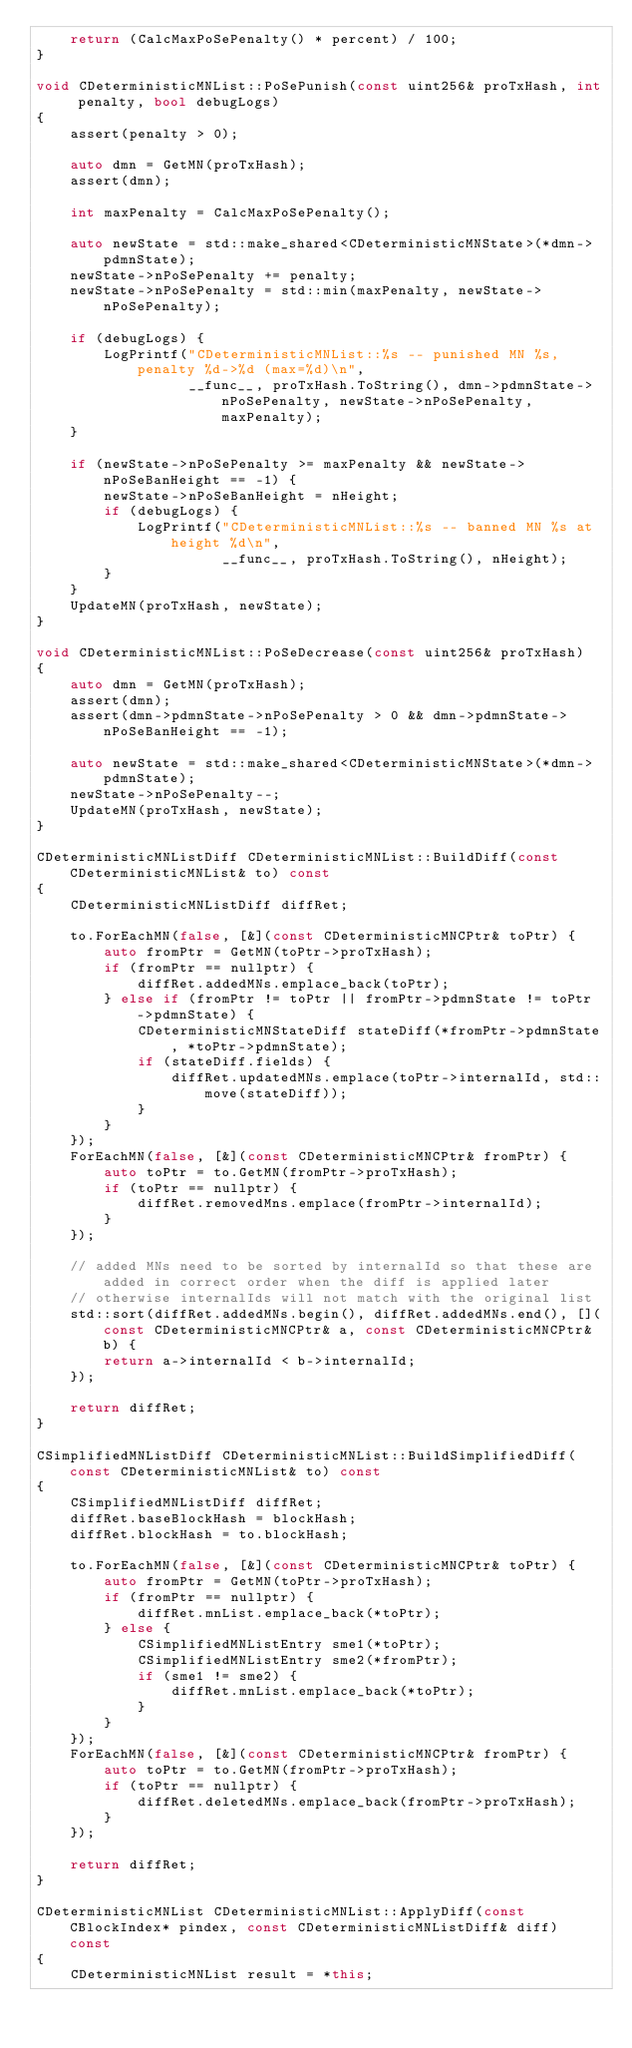Convert code to text. <code><loc_0><loc_0><loc_500><loc_500><_C++_>    return (CalcMaxPoSePenalty() * percent) / 100;
}

void CDeterministicMNList::PoSePunish(const uint256& proTxHash, int penalty, bool debugLogs)
{
    assert(penalty > 0);

    auto dmn = GetMN(proTxHash);
    assert(dmn);

    int maxPenalty = CalcMaxPoSePenalty();

    auto newState = std::make_shared<CDeterministicMNState>(*dmn->pdmnState);
    newState->nPoSePenalty += penalty;
    newState->nPoSePenalty = std::min(maxPenalty, newState->nPoSePenalty);

    if (debugLogs) {
        LogPrintf("CDeterministicMNList::%s -- punished MN %s, penalty %d->%d (max=%d)\n",
                  __func__, proTxHash.ToString(), dmn->pdmnState->nPoSePenalty, newState->nPoSePenalty, maxPenalty);
    }

    if (newState->nPoSePenalty >= maxPenalty && newState->nPoSeBanHeight == -1) {
        newState->nPoSeBanHeight = nHeight;
        if (debugLogs) {
            LogPrintf("CDeterministicMNList::%s -- banned MN %s at height %d\n",
                      __func__, proTxHash.ToString(), nHeight);
        }
    }
    UpdateMN(proTxHash, newState);
}

void CDeterministicMNList::PoSeDecrease(const uint256& proTxHash)
{
    auto dmn = GetMN(proTxHash);
    assert(dmn);
    assert(dmn->pdmnState->nPoSePenalty > 0 && dmn->pdmnState->nPoSeBanHeight == -1);

    auto newState = std::make_shared<CDeterministicMNState>(*dmn->pdmnState);
    newState->nPoSePenalty--;
    UpdateMN(proTxHash, newState);
}

CDeterministicMNListDiff CDeterministicMNList::BuildDiff(const CDeterministicMNList& to) const
{
    CDeterministicMNListDiff diffRet;

    to.ForEachMN(false, [&](const CDeterministicMNCPtr& toPtr) {
        auto fromPtr = GetMN(toPtr->proTxHash);
        if (fromPtr == nullptr) {
            diffRet.addedMNs.emplace_back(toPtr);
        } else if (fromPtr != toPtr || fromPtr->pdmnState != toPtr->pdmnState) {
            CDeterministicMNStateDiff stateDiff(*fromPtr->pdmnState, *toPtr->pdmnState);
            if (stateDiff.fields) {
                diffRet.updatedMNs.emplace(toPtr->internalId, std::move(stateDiff));
            }
        }
    });
    ForEachMN(false, [&](const CDeterministicMNCPtr& fromPtr) {
        auto toPtr = to.GetMN(fromPtr->proTxHash);
        if (toPtr == nullptr) {
            diffRet.removedMns.emplace(fromPtr->internalId);
        }
    });

    // added MNs need to be sorted by internalId so that these are added in correct order when the diff is applied later
    // otherwise internalIds will not match with the original list
    std::sort(diffRet.addedMNs.begin(), diffRet.addedMNs.end(), [](const CDeterministicMNCPtr& a, const CDeterministicMNCPtr& b) {
        return a->internalId < b->internalId;
    });

    return diffRet;
}

CSimplifiedMNListDiff CDeterministicMNList::BuildSimplifiedDiff(const CDeterministicMNList& to) const
{
    CSimplifiedMNListDiff diffRet;
    diffRet.baseBlockHash = blockHash;
    diffRet.blockHash = to.blockHash;

    to.ForEachMN(false, [&](const CDeterministicMNCPtr& toPtr) {
        auto fromPtr = GetMN(toPtr->proTxHash);
        if (fromPtr == nullptr) {
            diffRet.mnList.emplace_back(*toPtr);
        } else {
            CSimplifiedMNListEntry sme1(*toPtr);
            CSimplifiedMNListEntry sme2(*fromPtr);
            if (sme1 != sme2) {
                diffRet.mnList.emplace_back(*toPtr);
            }
        }
    });
    ForEachMN(false, [&](const CDeterministicMNCPtr& fromPtr) {
        auto toPtr = to.GetMN(fromPtr->proTxHash);
        if (toPtr == nullptr) {
            diffRet.deletedMNs.emplace_back(fromPtr->proTxHash);
        }
    });

    return diffRet;
}

CDeterministicMNList CDeterministicMNList::ApplyDiff(const CBlockIndex* pindex, const CDeterministicMNListDiff& diff) const
{
    CDeterministicMNList result = *this;</code> 